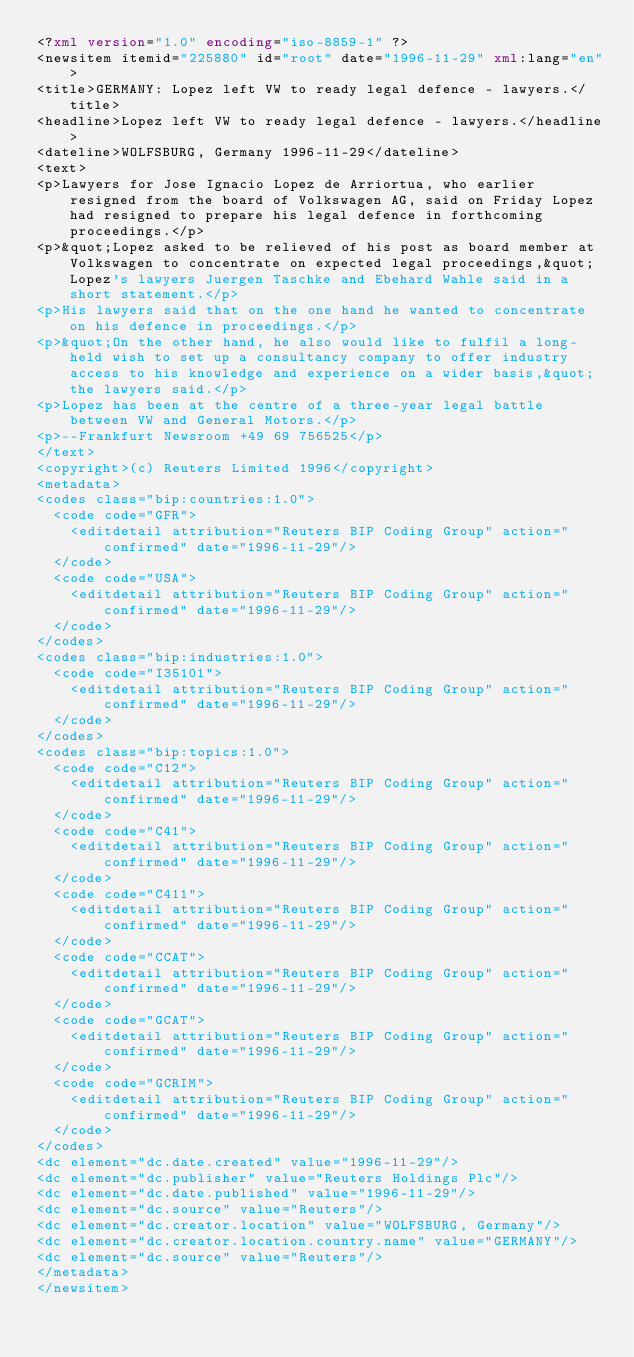Convert code to text. <code><loc_0><loc_0><loc_500><loc_500><_XML_><?xml version="1.0" encoding="iso-8859-1" ?>
<newsitem itemid="225880" id="root" date="1996-11-29" xml:lang="en">
<title>GERMANY: Lopez left VW to ready legal defence - lawyers.</title>
<headline>Lopez left VW to ready legal defence - lawyers.</headline>
<dateline>WOLFSBURG, Germany 1996-11-29</dateline>
<text>
<p>Lawyers for Jose Ignacio Lopez de Arriortua, who earlier resigned from the board of Volkswagen AG, said on Friday Lopez had resigned to prepare his legal defence in forthcoming proceedings.</p>
<p>&quot;Lopez asked to be relieved of his post as board member at Volkswagen to concentrate on expected legal proceedings,&quot; Lopez's lawyers Juergen Taschke and Ebehard Wahle said in a short statement.</p>
<p>His lawyers said that on the one hand he wanted to concentrate on his defence in proceedings.</p>
<p>&quot;On the other hand, he also would like to fulfil a long-held wish to set up a consultancy company to offer industry access to his knowledge and experience on a wider basis,&quot; the lawyers said.</p>
<p>Lopez has been at the centre of a three-year legal battle between VW and General Motors.</p>
<p>--Frankfurt Newsroom +49 69 756525</p>
</text>
<copyright>(c) Reuters Limited 1996</copyright>
<metadata>
<codes class="bip:countries:1.0">
  <code code="GFR">
    <editdetail attribution="Reuters BIP Coding Group" action="confirmed" date="1996-11-29"/>
  </code>
  <code code="USA">
    <editdetail attribution="Reuters BIP Coding Group" action="confirmed" date="1996-11-29"/>
  </code>
</codes>
<codes class="bip:industries:1.0">
  <code code="I35101">
    <editdetail attribution="Reuters BIP Coding Group" action="confirmed" date="1996-11-29"/>
  </code>
</codes>
<codes class="bip:topics:1.0">
  <code code="C12">
    <editdetail attribution="Reuters BIP Coding Group" action="confirmed" date="1996-11-29"/>
  </code>
  <code code="C41">
    <editdetail attribution="Reuters BIP Coding Group" action="confirmed" date="1996-11-29"/>
  </code>
  <code code="C411">
    <editdetail attribution="Reuters BIP Coding Group" action="confirmed" date="1996-11-29"/>
  </code>
  <code code="CCAT">
    <editdetail attribution="Reuters BIP Coding Group" action="confirmed" date="1996-11-29"/>
  </code>
  <code code="GCAT">
    <editdetail attribution="Reuters BIP Coding Group" action="confirmed" date="1996-11-29"/>
  </code>
  <code code="GCRIM">
    <editdetail attribution="Reuters BIP Coding Group" action="confirmed" date="1996-11-29"/>
  </code>
</codes>
<dc element="dc.date.created" value="1996-11-29"/>
<dc element="dc.publisher" value="Reuters Holdings Plc"/>
<dc element="dc.date.published" value="1996-11-29"/>
<dc element="dc.source" value="Reuters"/>
<dc element="dc.creator.location" value="WOLFSBURG, Germany"/>
<dc element="dc.creator.location.country.name" value="GERMANY"/>
<dc element="dc.source" value="Reuters"/>
</metadata>
</newsitem>
</code> 